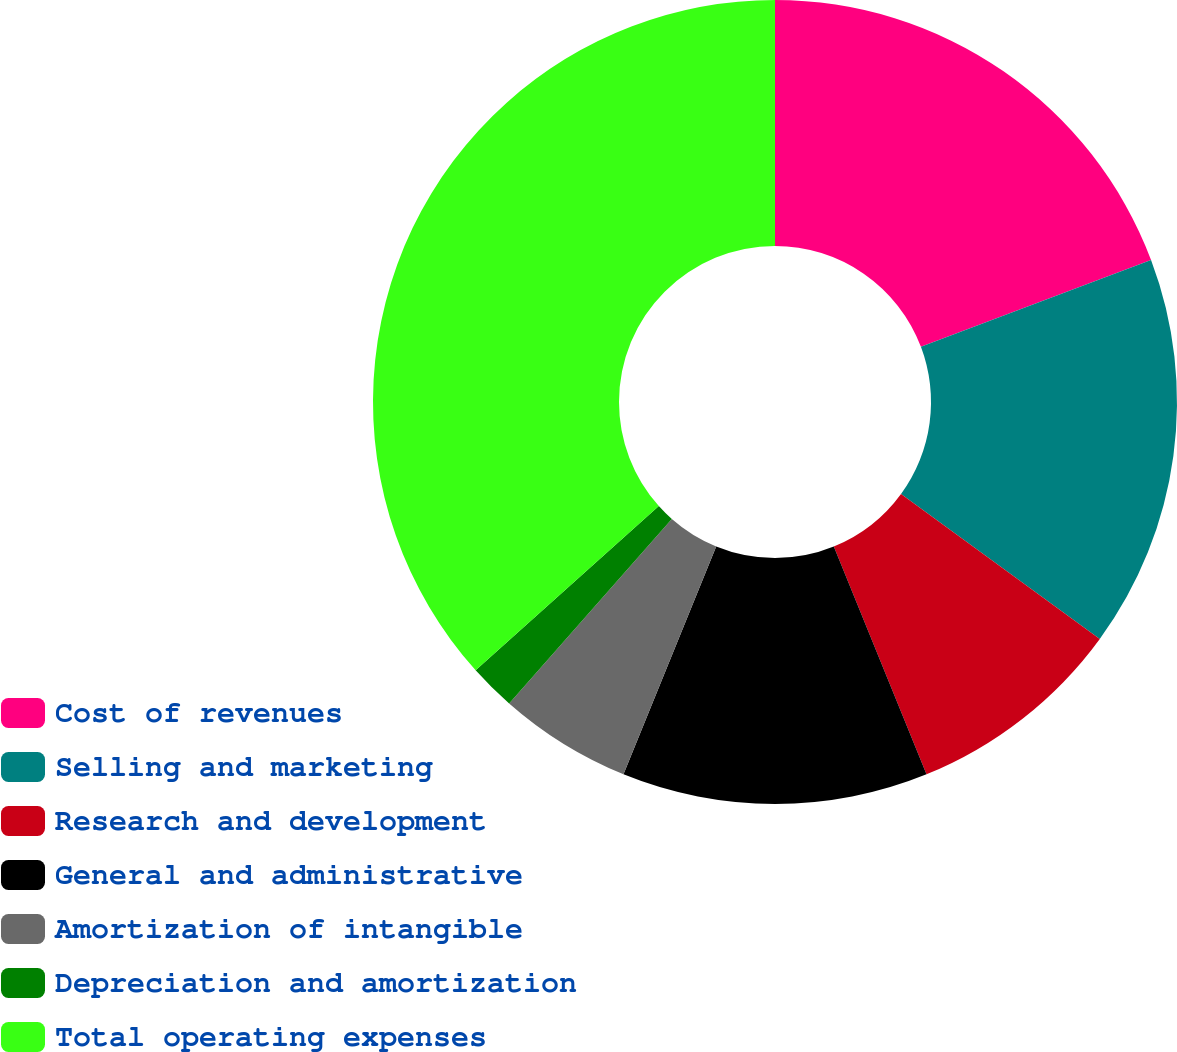Convert chart. <chart><loc_0><loc_0><loc_500><loc_500><pie_chart><fcel>Cost of revenues<fcel>Selling and marketing<fcel>Research and development<fcel>General and administrative<fcel>Amortization of intangible<fcel>Depreciation and amortization<fcel>Total operating expenses<nl><fcel>19.25%<fcel>15.78%<fcel>8.82%<fcel>12.3%<fcel>5.35%<fcel>1.87%<fcel>36.63%<nl></chart> 